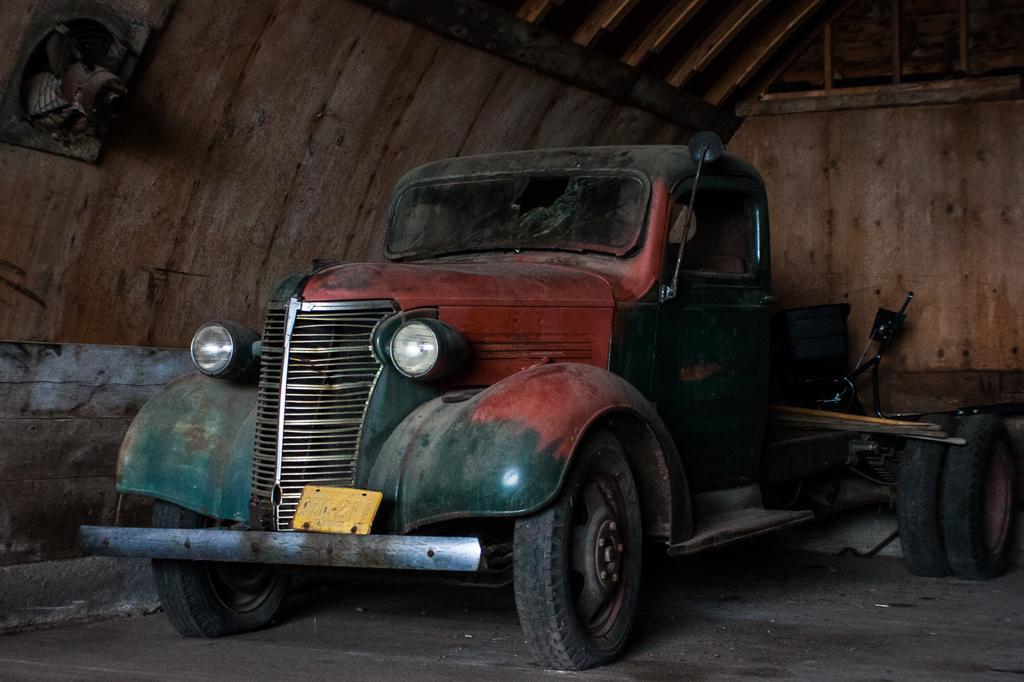Can you describe this image briefly? In this image I can see the vehicle, few objects, wooden shed and the exhaust-fan is attached to the shed. 